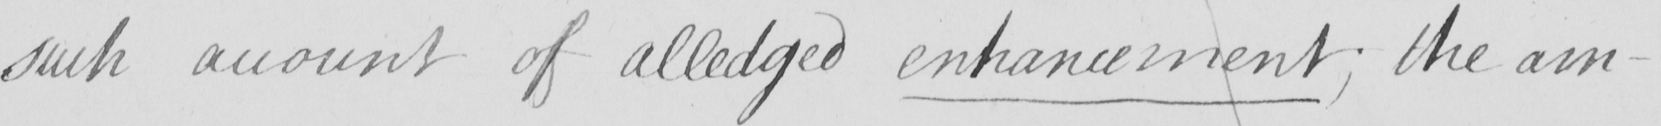Transcribe the text shown in this historical manuscript line. such account of alledged enhancement ; the am- 